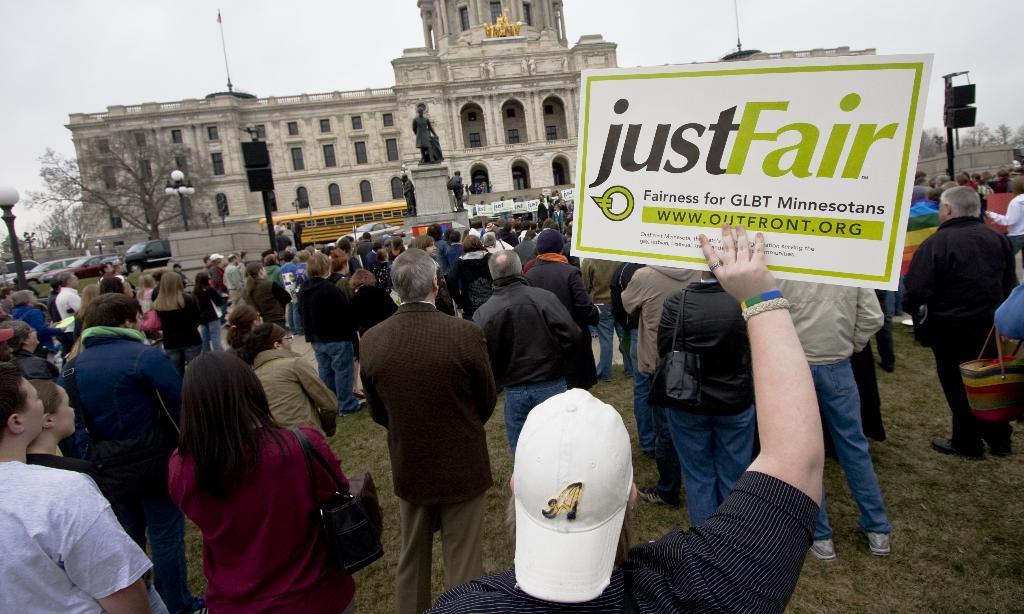In one or two sentences, can you explain what this image depicts? In this image there is the sky truncated towards the top of the image, there is a building truncated towards the top of the image, there is a tree, there are trees truncated towards the right of the image, there is sculptors, there are vehicles, there is a vehicle truncated towards the left of the image, there is a street light truncated towards the left of the image, there are poles, there are group of persons standing, there are persons holding an object, there are persons truncated towards the right of the image, there are persons truncated towards the bottom of the image, there are persons truncated towards the left of the image, there are boards, there is the text on the board. 